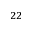<formula> <loc_0><loc_0><loc_500><loc_500>^ { 2 2 }</formula> 